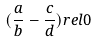Convert formula to latex. <formula><loc_0><loc_0><loc_500><loc_500>( \frac { a } { b } - \frac { c } { d } ) r e l 0</formula> 